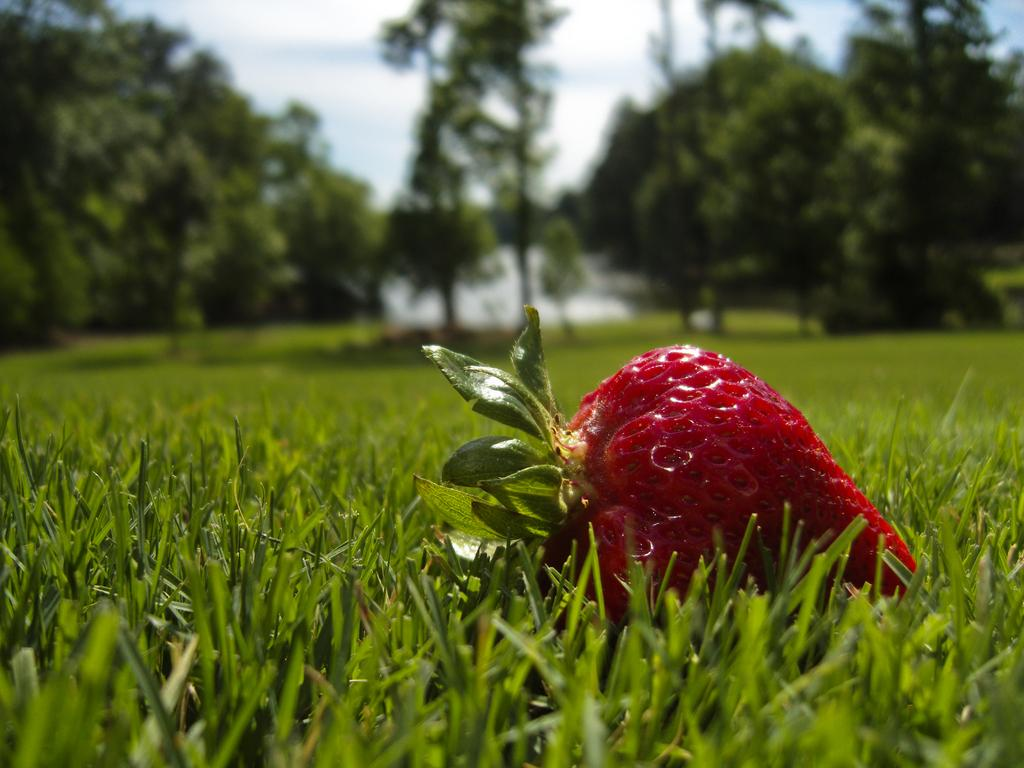What is located on the surface of the grass in the image? There is a strawberry on the surface of the grass. What can be seen in the background of the image? There are trees in the background of the image. What suggestion is being made by the strawberry in the image? There is no indication in the image that the strawberry is making a suggestion, as it is an inanimate object and cannot communicate. 